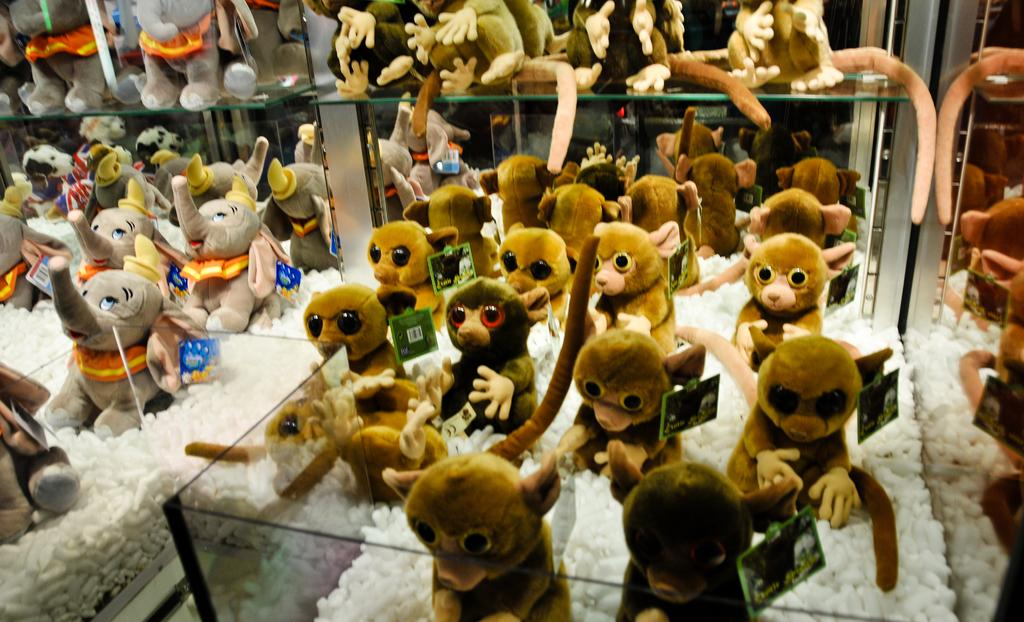What animals are present in the image? There is a monkey and an elephant in the image. What else can be seen in the image besides the animals? There are toys in a glass box in the image. What type of science experiment is being conducted by the monkey in the image? There is no science experiment being conducted by the monkey in the image; it is simply a monkey and an elephant in the presence of toys in a glass box. 